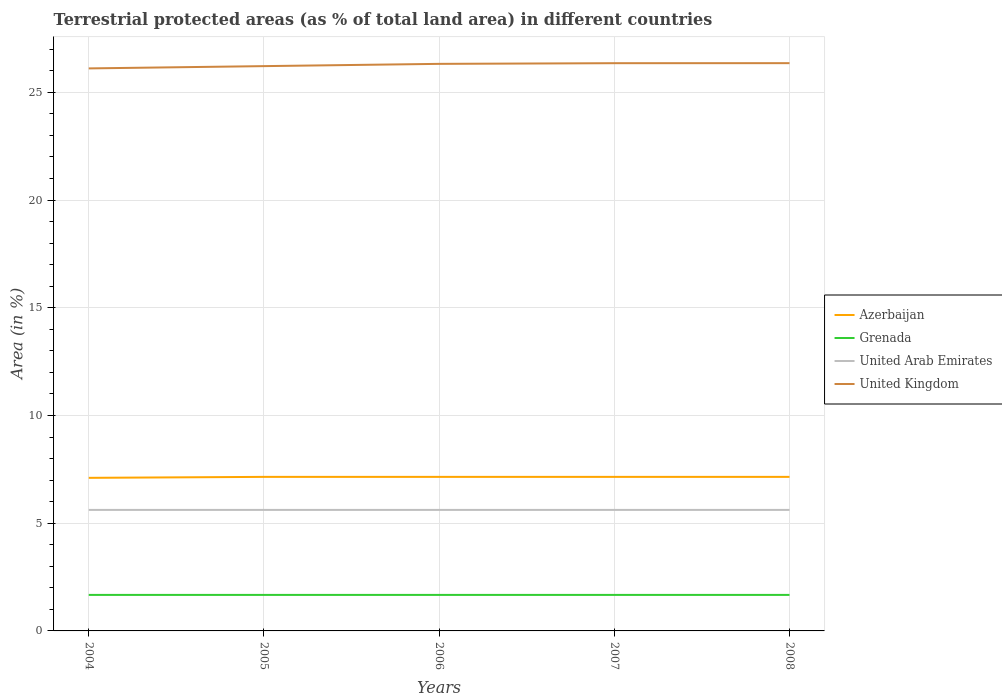Is the number of lines equal to the number of legend labels?
Your response must be concise. Yes. Across all years, what is the maximum percentage of terrestrial protected land in United Arab Emirates?
Offer a very short reply. 5.62. In which year was the percentage of terrestrial protected land in Grenada maximum?
Make the answer very short. 2004. What is the total percentage of terrestrial protected land in United Kingdom in the graph?
Keep it short and to the point. -0. What is the difference between the highest and the second highest percentage of terrestrial protected land in Azerbaijan?
Give a very brief answer. 0.04. Is the percentage of terrestrial protected land in United Arab Emirates strictly greater than the percentage of terrestrial protected land in United Kingdom over the years?
Your answer should be compact. Yes. Are the values on the major ticks of Y-axis written in scientific E-notation?
Offer a very short reply. No. What is the title of the graph?
Your response must be concise. Terrestrial protected areas (as % of total land area) in different countries. What is the label or title of the X-axis?
Ensure brevity in your answer.  Years. What is the label or title of the Y-axis?
Provide a succinct answer. Area (in %). What is the Area (in %) in Azerbaijan in 2004?
Offer a terse response. 7.1. What is the Area (in %) of Grenada in 2004?
Keep it short and to the point. 1.67. What is the Area (in %) in United Arab Emirates in 2004?
Your answer should be very brief. 5.62. What is the Area (in %) of United Kingdom in 2004?
Keep it short and to the point. 26.11. What is the Area (in %) of Azerbaijan in 2005?
Your answer should be compact. 7.15. What is the Area (in %) of Grenada in 2005?
Keep it short and to the point. 1.67. What is the Area (in %) in United Arab Emirates in 2005?
Your answer should be very brief. 5.62. What is the Area (in %) in United Kingdom in 2005?
Make the answer very short. 26.21. What is the Area (in %) of Azerbaijan in 2006?
Offer a terse response. 7.15. What is the Area (in %) of Grenada in 2006?
Ensure brevity in your answer.  1.67. What is the Area (in %) of United Arab Emirates in 2006?
Your answer should be compact. 5.62. What is the Area (in %) in United Kingdom in 2006?
Provide a succinct answer. 26.32. What is the Area (in %) in Azerbaijan in 2007?
Provide a succinct answer. 7.15. What is the Area (in %) in Grenada in 2007?
Your answer should be compact. 1.67. What is the Area (in %) in United Arab Emirates in 2007?
Your answer should be very brief. 5.62. What is the Area (in %) of United Kingdom in 2007?
Give a very brief answer. 26.35. What is the Area (in %) in Azerbaijan in 2008?
Provide a succinct answer. 7.15. What is the Area (in %) of Grenada in 2008?
Provide a succinct answer. 1.67. What is the Area (in %) in United Arab Emirates in 2008?
Keep it short and to the point. 5.62. What is the Area (in %) in United Kingdom in 2008?
Offer a very short reply. 26.35. Across all years, what is the maximum Area (in %) of Azerbaijan?
Make the answer very short. 7.15. Across all years, what is the maximum Area (in %) of Grenada?
Provide a succinct answer. 1.67. Across all years, what is the maximum Area (in %) in United Arab Emirates?
Offer a terse response. 5.62. Across all years, what is the maximum Area (in %) in United Kingdom?
Make the answer very short. 26.35. Across all years, what is the minimum Area (in %) of Azerbaijan?
Your answer should be compact. 7.1. Across all years, what is the minimum Area (in %) in Grenada?
Your answer should be very brief. 1.67. Across all years, what is the minimum Area (in %) of United Arab Emirates?
Provide a succinct answer. 5.62. Across all years, what is the minimum Area (in %) in United Kingdom?
Provide a short and direct response. 26.11. What is the total Area (in %) of Azerbaijan in the graph?
Provide a succinct answer. 35.7. What is the total Area (in %) in Grenada in the graph?
Your answer should be very brief. 8.36. What is the total Area (in %) of United Arab Emirates in the graph?
Provide a succinct answer. 28.09. What is the total Area (in %) of United Kingdom in the graph?
Keep it short and to the point. 131.34. What is the difference between the Area (in %) of Azerbaijan in 2004 and that in 2005?
Provide a short and direct response. -0.04. What is the difference between the Area (in %) in Grenada in 2004 and that in 2005?
Provide a succinct answer. 0. What is the difference between the Area (in %) of United Arab Emirates in 2004 and that in 2005?
Make the answer very short. 0. What is the difference between the Area (in %) of United Kingdom in 2004 and that in 2005?
Give a very brief answer. -0.11. What is the difference between the Area (in %) of Azerbaijan in 2004 and that in 2006?
Offer a terse response. -0.04. What is the difference between the Area (in %) in United Kingdom in 2004 and that in 2006?
Keep it short and to the point. -0.21. What is the difference between the Area (in %) in Azerbaijan in 2004 and that in 2007?
Your answer should be very brief. -0.04. What is the difference between the Area (in %) in Grenada in 2004 and that in 2007?
Offer a terse response. 0. What is the difference between the Area (in %) in United Arab Emirates in 2004 and that in 2007?
Provide a succinct answer. 0. What is the difference between the Area (in %) of United Kingdom in 2004 and that in 2007?
Your answer should be very brief. -0.24. What is the difference between the Area (in %) of Azerbaijan in 2004 and that in 2008?
Offer a terse response. -0.04. What is the difference between the Area (in %) of United Arab Emirates in 2004 and that in 2008?
Give a very brief answer. 0. What is the difference between the Area (in %) in United Kingdom in 2004 and that in 2008?
Provide a short and direct response. -0.24. What is the difference between the Area (in %) in United Arab Emirates in 2005 and that in 2006?
Provide a short and direct response. 0. What is the difference between the Area (in %) of United Kingdom in 2005 and that in 2006?
Make the answer very short. -0.1. What is the difference between the Area (in %) of Grenada in 2005 and that in 2007?
Your answer should be very brief. 0. What is the difference between the Area (in %) in United Kingdom in 2005 and that in 2007?
Your answer should be compact. -0.14. What is the difference between the Area (in %) in Grenada in 2005 and that in 2008?
Provide a succinct answer. 0. What is the difference between the Area (in %) in United Arab Emirates in 2005 and that in 2008?
Your answer should be very brief. 0. What is the difference between the Area (in %) of United Kingdom in 2005 and that in 2008?
Provide a short and direct response. -0.14. What is the difference between the Area (in %) of Azerbaijan in 2006 and that in 2007?
Your response must be concise. 0. What is the difference between the Area (in %) in United Kingdom in 2006 and that in 2007?
Your response must be concise. -0.03. What is the difference between the Area (in %) of United Arab Emirates in 2006 and that in 2008?
Your response must be concise. 0. What is the difference between the Area (in %) in United Kingdom in 2006 and that in 2008?
Provide a short and direct response. -0.03. What is the difference between the Area (in %) of Azerbaijan in 2007 and that in 2008?
Your response must be concise. 0. What is the difference between the Area (in %) in Grenada in 2007 and that in 2008?
Make the answer very short. 0. What is the difference between the Area (in %) in United Arab Emirates in 2007 and that in 2008?
Provide a short and direct response. 0. What is the difference between the Area (in %) of United Kingdom in 2007 and that in 2008?
Your answer should be very brief. -0. What is the difference between the Area (in %) in Azerbaijan in 2004 and the Area (in %) in Grenada in 2005?
Your answer should be compact. 5.43. What is the difference between the Area (in %) of Azerbaijan in 2004 and the Area (in %) of United Arab Emirates in 2005?
Your answer should be compact. 1.49. What is the difference between the Area (in %) of Azerbaijan in 2004 and the Area (in %) of United Kingdom in 2005?
Your answer should be very brief. -19.11. What is the difference between the Area (in %) in Grenada in 2004 and the Area (in %) in United Arab Emirates in 2005?
Ensure brevity in your answer.  -3.95. What is the difference between the Area (in %) in Grenada in 2004 and the Area (in %) in United Kingdom in 2005?
Offer a terse response. -24.54. What is the difference between the Area (in %) of United Arab Emirates in 2004 and the Area (in %) of United Kingdom in 2005?
Your response must be concise. -20.6. What is the difference between the Area (in %) of Azerbaijan in 2004 and the Area (in %) of Grenada in 2006?
Give a very brief answer. 5.43. What is the difference between the Area (in %) in Azerbaijan in 2004 and the Area (in %) in United Arab Emirates in 2006?
Your answer should be compact. 1.49. What is the difference between the Area (in %) of Azerbaijan in 2004 and the Area (in %) of United Kingdom in 2006?
Ensure brevity in your answer.  -19.21. What is the difference between the Area (in %) of Grenada in 2004 and the Area (in %) of United Arab Emirates in 2006?
Offer a very short reply. -3.95. What is the difference between the Area (in %) of Grenada in 2004 and the Area (in %) of United Kingdom in 2006?
Your answer should be very brief. -24.65. What is the difference between the Area (in %) in United Arab Emirates in 2004 and the Area (in %) in United Kingdom in 2006?
Provide a succinct answer. -20.7. What is the difference between the Area (in %) in Azerbaijan in 2004 and the Area (in %) in Grenada in 2007?
Provide a short and direct response. 5.43. What is the difference between the Area (in %) of Azerbaijan in 2004 and the Area (in %) of United Arab Emirates in 2007?
Ensure brevity in your answer.  1.49. What is the difference between the Area (in %) in Azerbaijan in 2004 and the Area (in %) in United Kingdom in 2007?
Make the answer very short. -19.25. What is the difference between the Area (in %) of Grenada in 2004 and the Area (in %) of United Arab Emirates in 2007?
Your answer should be very brief. -3.95. What is the difference between the Area (in %) in Grenada in 2004 and the Area (in %) in United Kingdom in 2007?
Offer a terse response. -24.68. What is the difference between the Area (in %) of United Arab Emirates in 2004 and the Area (in %) of United Kingdom in 2007?
Give a very brief answer. -20.73. What is the difference between the Area (in %) in Azerbaijan in 2004 and the Area (in %) in Grenada in 2008?
Offer a terse response. 5.43. What is the difference between the Area (in %) of Azerbaijan in 2004 and the Area (in %) of United Arab Emirates in 2008?
Your response must be concise. 1.49. What is the difference between the Area (in %) in Azerbaijan in 2004 and the Area (in %) in United Kingdom in 2008?
Provide a succinct answer. -19.25. What is the difference between the Area (in %) of Grenada in 2004 and the Area (in %) of United Arab Emirates in 2008?
Offer a very short reply. -3.95. What is the difference between the Area (in %) in Grenada in 2004 and the Area (in %) in United Kingdom in 2008?
Your answer should be very brief. -24.68. What is the difference between the Area (in %) of United Arab Emirates in 2004 and the Area (in %) of United Kingdom in 2008?
Offer a very short reply. -20.73. What is the difference between the Area (in %) of Azerbaijan in 2005 and the Area (in %) of Grenada in 2006?
Ensure brevity in your answer.  5.48. What is the difference between the Area (in %) of Azerbaijan in 2005 and the Area (in %) of United Arab Emirates in 2006?
Keep it short and to the point. 1.53. What is the difference between the Area (in %) of Azerbaijan in 2005 and the Area (in %) of United Kingdom in 2006?
Provide a succinct answer. -19.17. What is the difference between the Area (in %) of Grenada in 2005 and the Area (in %) of United Arab Emirates in 2006?
Provide a succinct answer. -3.95. What is the difference between the Area (in %) of Grenada in 2005 and the Area (in %) of United Kingdom in 2006?
Make the answer very short. -24.65. What is the difference between the Area (in %) of United Arab Emirates in 2005 and the Area (in %) of United Kingdom in 2006?
Your answer should be compact. -20.7. What is the difference between the Area (in %) of Azerbaijan in 2005 and the Area (in %) of Grenada in 2007?
Make the answer very short. 5.48. What is the difference between the Area (in %) in Azerbaijan in 2005 and the Area (in %) in United Arab Emirates in 2007?
Provide a succinct answer. 1.53. What is the difference between the Area (in %) of Azerbaijan in 2005 and the Area (in %) of United Kingdom in 2007?
Your answer should be compact. -19.2. What is the difference between the Area (in %) of Grenada in 2005 and the Area (in %) of United Arab Emirates in 2007?
Provide a succinct answer. -3.95. What is the difference between the Area (in %) in Grenada in 2005 and the Area (in %) in United Kingdom in 2007?
Provide a succinct answer. -24.68. What is the difference between the Area (in %) in United Arab Emirates in 2005 and the Area (in %) in United Kingdom in 2007?
Your answer should be very brief. -20.73. What is the difference between the Area (in %) of Azerbaijan in 2005 and the Area (in %) of Grenada in 2008?
Your answer should be very brief. 5.48. What is the difference between the Area (in %) of Azerbaijan in 2005 and the Area (in %) of United Arab Emirates in 2008?
Keep it short and to the point. 1.53. What is the difference between the Area (in %) in Azerbaijan in 2005 and the Area (in %) in United Kingdom in 2008?
Your response must be concise. -19.2. What is the difference between the Area (in %) of Grenada in 2005 and the Area (in %) of United Arab Emirates in 2008?
Make the answer very short. -3.95. What is the difference between the Area (in %) of Grenada in 2005 and the Area (in %) of United Kingdom in 2008?
Offer a very short reply. -24.68. What is the difference between the Area (in %) of United Arab Emirates in 2005 and the Area (in %) of United Kingdom in 2008?
Ensure brevity in your answer.  -20.73. What is the difference between the Area (in %) of Azerbaijan in 2006 and the Area (in %) of Grenada in 2007?
Keep it short and to the point. 5.48. What is the difference between the Area (in %) of Azerbaijan in 2006 and the Area (in %) of United Arab Emirates in 2007?
Your answer should be very brief. 1.53. What is the difference between the Area (in %) in Azerbaijan in 2006 and the Area (in %) in United Kingdom in 2007?
Provide a short and direct response. -19.2. What is the difference between the Area (in %) of Grenada in 2006 and the Area (in %) of United Arab Emirates in 2007?
Provide a short and direct response. -3.95. What is the difference between the Area (in %) in Grenada in 2006 and the Area (in %) in United Kingdom in 2007?
Make the answer very short. -24.68. What is the difference between the Area (in %) of United Arab Emirates in 2006 and the Area (in %) of United Kingdom in 2007?
Provide a succinct answer. -20.73. What is the difference between the Area (in %) of Azerbaijan in 2006 and the Area (in %) of Grenada in 2008?
Offer a very short reply. 5.48. What is the difference between the Area (in %) in Azerbaijan in 2006 and the Area (in %) in United Arab Emirates in 2008?
Offer a terse response. 1.53. What is the difference between the Area (in %) of Azerbaijan in 2006 and the Area (in %) of United Kingdom in 2008?
Give a very brief answer. -19.2. What is the difference between the Area (in %) in Grenada in 2006 and the Area (in %) in United Arab Emirates in 2008?
Make the answer very short. -3.95. What is the difference between the Area (in %) of Grenada in 2006 and the Area (in %) of United Kingdom in 2008?
Provide a short and direct response. -24.68. What is the difference between the Area (in %) of United Arab Emirates in 2006 and the Area (in %) of United Kingdom in 2008?
Provide a short and direct response. -20.73. What is the difference between the Area (in %) of Azerbaijan in 2007 and the Area (in %) of Grenada in 2008?
Provide a short and direct response. 5.48. What is the difference between the Area (in %) in Azerbaijan in 2007 and the Area (in %) in United Arab Emirates in 2008?
Provide a succinct answer. 1.53. What is the difference between the Area (in %) in Azerbaijan in 2007 and the Area (in %) in United Kingdom in 2008?
Provide a short and direct response. -19.2. What is the difference between the Area (in %) in Grenada in 2007 and the Area (in %) in United Arab Emirates in 2008?
Offer a very short reply. -3.95. What is the difference between the Area (in %) of Grenada in 2007 and the Area (in %) of United Kingdom in 2008?
Make the answer very short. -24.68. What is the difference between the Area (in %) of United Arab Emirates in 2007 and the Area (in %) of United Kingdom in 2008?
Your answer should be very brief. -20.73. What is the average Area (in %) in Azerbaijan per year?
Your answer should be compact. 7.14. What is the average Area (in %) of Grenada per year?
Keep it short and to the point. 1.67. What is the average Area (in %) of United Arab Emirates per year?
Ensure brevity in your answer.  5.62. What is the average Area (in %) of United Kingdom per year?
Your answer should be very brief. 26.27. In the year 2004, what is the difference between the Area (in %) in Azerbaijan and Area (in %) in Grenada?
Offer a very short reply. 5.43. In the year 2004, what is the difference between the Area (in %) of Azerbaijan and Area (in %) of United Arab Emirates?
Provide a short and direct response. 1.49. In the year 2004, what is the difference between the Area (in %) of Azerbaijan and Area (in %) of United Kingdom?
Give a very brief answer. -19. In the year 2004, what is the difference between the Area (in %) of Grenada and Area (in %) of United Arab Emirates?
Keep it short and to the point. -3.95. In the year 2004, what is the difference between the Area (in %) in Grenada and Area (in %) in United Kingdom?
Your response must be concise. -24.44. In the year 2004, what is the difference between the Area (in %) of United Arab Emirates and Area (in %) of United Kingdom?
Offer a very short reply. -20.49. In the year 2005, what is the difference between the Area (in %) in Azerbaijan and Area (in %) in Grenada?
Make the answer very short. 5.48. In the year 2005, what is the difference between the Area (in %) of Azerbaijan and Area (in %) of United Arab Emirates?
Keep it short and to the point. 1.53. In the year 2005, what is the difference between the Area (in %) in Azerbaijan and Area (in %) in United Kingdom?
Make the answer very short. -19.07. In the year 2005, what is the difference between the Area (in %) in Grenada and Area (in %) in United Arab Emirates?
Your answer should be very brief. -3.95. In the year 2005, what is the difference between the Area (in %) of Grenada and Area (in %) of United Kingdom?
Your answer should be compact. -24.54. In the year 2005, what is the difference between the Area (in %) of United Arab Emirates and Area (in %) of United Kingdom?
Provide a succinct answer. -20.6. In the year 2006, what is the difference between the Area (in %) in Azerbaijan and Area (in %) in Grenada?
Keep it short and to the point. 5.48. In the year 2006, what is the difference between the Area (in %) in Azerbaijan and Area (in %) in United Arab Emirates?
Offer a very short reply. 1.53. In the year 2006, what is the difference between the Area (in %) in Azerbaijan and Area (in %) in United Kingdom?
Offer a terse response. -19.17. In the year 2006, what is the difference between the Area (in %) in Grenada and Area (in %) in United Arab Emirates?
Provide a succinct answer. -3.95. In the year 2006, what is the difference between the Area (in %) of Grenada and Area (in %) of United Kingdom?
Your response must be concise. -24.65. In the year 2006, what is the difference between the Area (in %) in United Arab Emirates and Area (in %) in United Kingdom?
Offer a very short reply. -20.7. In the year 2007, what is the difference between the Area (in %) in Azerbaijan and Area (in %) in Grenada?
Provide a short and direct response. 5.48. In the year 2007, what is the difference between the Area (in %) of Azerbaijan and Area (in %) of United Arab Emirates?
Your response must be concise. 1.53. In the year 2007, what is the difference between the Area (in %) in Azerbaijan and Area (in %) in United Kingdom?
Your response must be concise. -19.2. In the year 2007, what is the difference between the Area (in %) of Grenada and Area (in %) of United Arab Emirates?
Your answer should be compact. -3.95. In the year 2007, what is the difference between the Area (in %) in Grenada and Area (in %) in United Kingdom?
Give a very brief answer. -24.68. In the year 2007, what is the difference between the Area (in %) in United Arab Emirates and Area (in %) in United Kingdom?
Ensure brevity in your answer.  -20.73. In the year 2008, what is the difference between the Area (in %) of Azerbaijan and Area (in %) of Grenada?
Your response must be concise. 5.48. In the year 2008, what is the difference between the Area (in %) in Azerbaijan and Area (in %) in United Arab Emirates?
Ensure brevity in your answer.  1.53. In the year 2008, what is the difference between the Area (in %) of Azerbaijan and Area (in %) of United Kingdom?
Provide a succinct answer. -19.2. In the year 2008, what is the difference between the Area (in %) in Grenada and Area (in %) in United Arab Emirates?
Your response must be concise. -3.95. In the year 2008, what is the difference between the Area (in %) of Grenada and Area (in %) of United Kingdom?
Ensure brevity in your answer.  -24.68. In the year 2008, what is the difference between the Area (in %) in United Arab Emirates and Area (in %) in United Kingdom?
Give a very brief answer. -20.73. What is the ratio of the Area (in %) in Grenada in 2004 to that in 2005?
Provide a short and direct response. 1. What is the ratio of the Area (in %) of United Kingdom in 2004 to that in 2005?
Provide a short and direct response. 1. What is the ratio of the Area (in %) of Grenada in 2004 to that in 2006?
Offer a very short reply. 1. What is the ratio of the Area (in %) in United Arab Emirates in 2004 to that in 2006?
Your response must be concise. 1. What is the ratio of the Area (in %) in United Kingdom in 2004 to that in 2006?
Give a very brief answer. 0.99. What is the ratio of the Area (in %) in United Kingdom in 2004 to that in 2007?
Your answer should be very brief. 0.99. What is the ratio of the Area (in %) in Grenada in 2004 to that in 2008?
Offer a very short reply. 1. What is the ratio of the Area (in %) in Azerbaijan in 2005 to that in 2006?
Your response must be concise. 1. What is the ratio of the Area (in %) of United Arab Emirates in 2005 to that in 2006?
Give a very brief answer. 1. What is the ratio of the Area (in %) in United Kingdom in 2005 to that in 2006?
Your answer should be compact. 1. What is the ratio of the Area (in %) of Azerbaijan in 2005 to that in 2007?
Your response must be concise. 1. What is the ratio of the Area (in %) in Grenada in 2005 to that in 2007?
Keep it short and to the point. 1. What is the ratio of the Area (in %) in United Kingdom in 2005 to that in 2007?
Your answer should be compact. 0.99. What is the ratio of the Area (in %) in United Arab Emirates in 2005 to that in 2008?
Offer a terse response. 1. What is the ratio of the Area (in %) of United Kingdom in 2005 to that in 2008?
Give a very brief answer. 0.99. What is the ratio of the Area (in %) in Azerbaijan in 2006 to that in 2007?
Make the answer very short. 1. What is the ratio of the Area (in %) of Grenada in 2006 to that in 2007?
Provide a short and direct response. 1. What is the ratio of the Area (in %) in Grenada in 2006 to that in 2008?
Offer a terse response. 1. What is the ratio of the Area (in %) of United Arab Emirates in 2006 to that in 2008?
Offer a very short reply. 1. What is the ratio of the Area (in %) of United Kingdom in 2006 to that in 2008?
Give a very brief answer. 1. What is the ratio of the Area (in %) of Azerbaijan in 2007 to that in 2008?
Provide a short and direct response. 1. What is the ratio of the Area (in %) in Grenada in 2007 to that in 2008?
Your answer should be very brief. 1. What is the ratio of the Area (in %) in United Arab Emirates in 2007 to that in 2008?
Keep it short and to the point. 1. What is the difference between the highest and the second highest Area (in %) of United Arab Emirates?
Your response must be concise. 0. What is the difference between the highest and the second highest Area (in %) in United Kingdom?
Provide a short and direct response. 0. What is the difference between the highest and the lowest Area (in %) in Azerbaijan?
Give a very brief answer. 0.04. What is the difference between the highest and the lowest Area (in %) in United Kingdom?
Your answer should be compact. 0.24. 